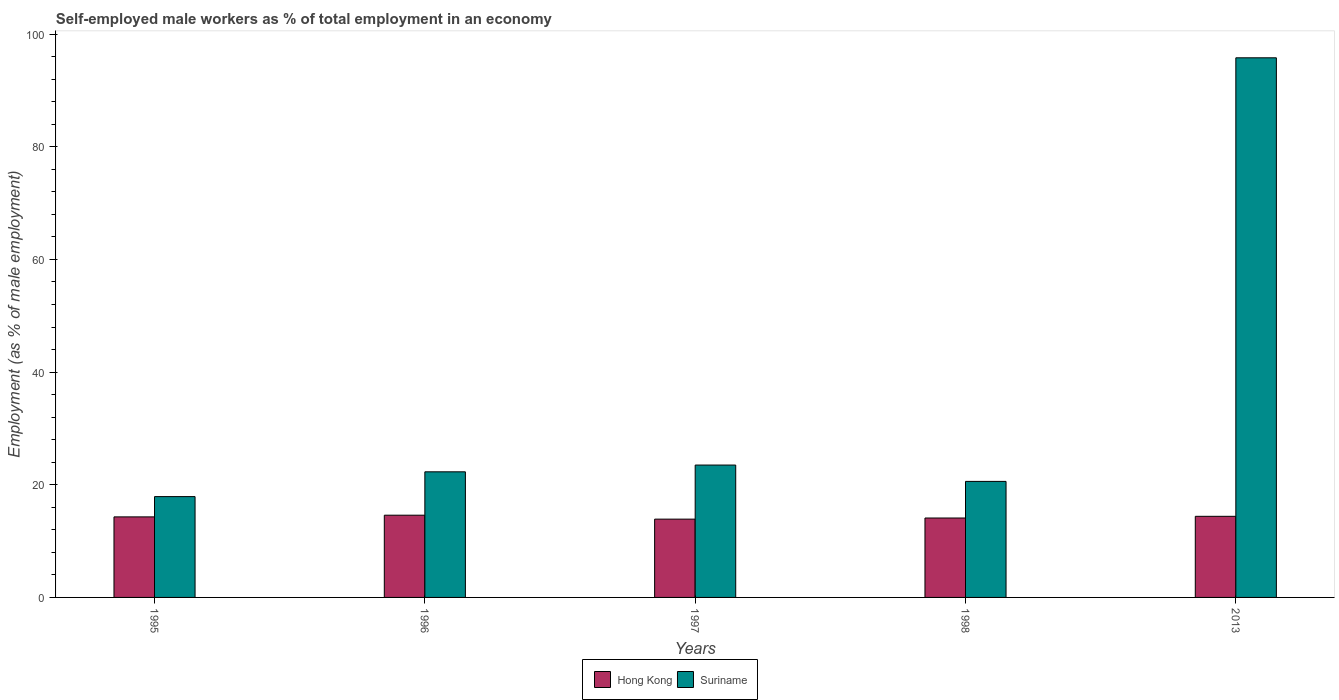Are the number of bars per tick equal to the number of legend labels?
Provide a short and direct response. Yes. How many bars are there on the 5th tick from the left?
Ensure brevity in your answer.  2. How many bars are there on the 1st tick from the right?
Offer a terse response. 2. Across all years, what is the maximum percentage of self-employed male workers in Hong Kong?
Your response must be concise. 14.6. Across all years, what is the minimum percentage of self-employed male workers in Suriname?
Provide a succinct answer. 17.9. In which year was the percentage of self-employed male workers in Suriname minimum?
Ensure brevity in your answer.  1995. What is the total percentage of self-employed male workers in Hong Kong in the graph?
Your response must be concise. 71.3. What is the difference between the percentage of self-employed male workers in Hong Kong in 2013 and the percentage of self-employed male workers in Suriname in 1995?
Provide a succinct answer. -3.5. What is the average percentage of self-employed male workers in Hong Kong per year?
Your answer should be very brief. 14.26. In the year 1998, what is the difference between the percentage of self-employed male workers in Hong Kong and percentage of self-employed male workers in Suriname?
Provide a short and direct response. -6.5. What is the ratio of the percentage of self-employed male workers in Hong Kong in 1997 to that in 1998?
Give a very brief answer. 0.99. Is the percentage of self-employed male workers in Suriname in 1997 less than that in 1998?
Make the answer very short. No. Is the difference between the percentage of self-employed male workers in Hong Kong in 1997 and 2013 greater than the difference between the percentage of self-employed male workers in Suriname in 1997 and 2013?
Offer a very short reply. Yes. What is the difference between the highest and the second highest percentage of self-employed male workers in Suriname?
Provide a short and direct response. 72.3. What is the difference between the highest and the lowest percentage of self-employed male workers in Suriname?
Your response must be concise. 77.9. In how many years, is the percentage of self-employed male workers in Hong Kong greater than the average percentage of self-employed male workers in Hong Kong taken over all years?
Your answer should be compact. 3. Is the sum of the percentage of self-employed male workers in Suriname in 1998 and 2013 greater than the maximum percentage of self-employed male workers in Hong Kong across all years?
Provide a short and direct response. Yes. What does the 1st bar from the left in 2013 represents?
Ensure brevity in your answer.  Hong Kong. What does the 2nd bar from the right in 1995 represents?
Give a very brief answer. Hong Kong. Are all the bars in the graph horizontal?
Your answer should be very brief. No. How many years are there in the graph?
Provide a succinct answer. 5. What is the difference between two consecutive major ticks on the Y-axis?
Offer a terse response. 20. Does the graph contain any zero values?
Keep it short and to the point. No. What is the title of the graph?
Your response must be concise. Self-employed male workers as % of total employment in an economy. What is the label or title of the Y-axis?
Give a very brief answer. Employment (as % of male employment). What is the Employment (as % of male employment) of Hong Kong in 1995?
Your answer should be compact. 14.3. What is the Employment (as % of male employment) in Suriname in 1995?
Your answer should be compact. 17.9. What is the Employment (as % of male employment) in Hong Kong in 1996?
Make the answer very short. 14.6. What is the Employment (as % of male employment) in Suriname in 1996?
Your answer should be compact. 22.3. What is the Employment (as % of male employment) in Hong Kong in 1997?
Provide a short and direct response. 13.9. What is the Employment (as % of male employment) of Suriname in 1997?
Provide a succinct answer. 23.5. What is the Employment (as % of male employment) in Hong Kong in 1998?
Provide a succinct answer. 14.1. What is the Employment (as % of male employment) in Suriname in 1998?
Offer a terse response. 20.6. What is the Employment (as % of male employment) of Hong Kong in 2013?
Ensure brevity in your answer.  14.4. What is the Employment (as % of male employment) in Suriname in 2013?
Give a very brief answer. 95.8. Across all years, what is the maximum Employment (as % of male employment) of Hong Kong?
Provide a short and direct response. 14.6. Across all years, what is the maximum Employment (as % of male employment) in Suriname?
Make the answer very short. 95.8. Across all years, what is the minimum Employment (as % of male employment) of Hong Kong?
Keep it short and to the point. 13.9. Across all years, what is the minimum Employment (as % of male employment) of Suriname?
Your answer should be very brief. 17.9. What is the total Employment (as % of male employment) of Hong Kong in the graph?
Your response must be concise. 71.3. What is the total Employment (as % of male employment) in Suriname in the graph?
Your answer should be compact. 180.1. What is the difference between the Employment (as % of male employment) in Suriname in 1995 and that in 1996?
Offer a very short reply. -4.4. What is the difference between the Employment (as % of male employment) of Hong Kong in 1995 and that in 1998?
Your response must be concise. 0.2. What is the difference between the Employment (as % of male employment) of Suriname in 1995 and that in 1998?
Ensure brevity in your answer.  -2.7. What is the difference between the Employment (as % of male employment) of Suriname in 1995 and that in 2013?
Give a very brief answer. -77.9. What is the difference between the Employment (as % of male employment) in Hong Kong in 1996 and that in 1997?
Give a very brief answer. 0.7. What is the difference between the Employment (as % of male employment) of Suriname in 1996 and that in 1997?
Give a very brief answer. -1.2. What is the difference between the Employment (as % of male employment) in Hong Kong in 1996 and that in 2013?
Make the answer very short. 0.2. What is the difference between the Employment (as % of male employment) in Suriname in 1996 and that in 2013?
Keep it short and to the point. -73.5. What is the difference between the Employment (as % of male employment) in Hong Kong in 1997 and that in 1998?
Provide a succinct answer. -0.2. What is the difference between the Employment (as % of male employment) in Hong Kong in 1997 and that in 2013?
Keep it short and to the point. -0.5. What is the difference between the Employment (as % of male employment) of Suriname in 1997 and that in 2013?
Keep it short and to the point. -72.3. What is the difference between the Employment (as % of male employment) of Hong Kong in 1998 and that in 2013?
Make the answer very short. -0.3. What is the difference between the Employment (as % of male employment) in Suriname in 1998 and that in 2013?
Offer a terse response. -75.2. What is the difference between the Employment (as % of male employment) in Hong Kong in 1995 and the Employment (as % of male employment) in Suriname in 1996?
Your answer should be very brief. -8. What is the difference between the Employment (as % of male employment) of Hong Kong in 1995 and the Employment (as % of male employment) of Suriname in 1997?
Offer a terse response. -9.2. What is the difference between the Employment (as % of male employment) of Hong Kong in 1995 and the Employment (as % of male employment) of Suriname in 1998?
Keep it short and to the point. -6.3. What is the difference between the Employment (as % of male employment) in Hong Kong in 1995 and the Employment (as % of male employment) in Suriname in 2013?
Keep it short and to the point. -81.5. What is the difference between the Employment (as % of male employment) of Hong Kong in 1996 and the Employment (as % of male employment) of Suriname in 1997?
Ensure brevity in your answer.  -8.9. What is the difference between the Employment (as % of male employment) in Hong Kong in 1996 and the Employment (as % of male employment) in Suriname in 1998?
Offer a terse response. -6. What is the difference between the Employment (as % of male employment) of Hong Kong in 1996 and the Employment (as % of male employment) of Suriname in 2013?
Give a very brief answer. -81.2. What is the difference between the Employment (as % of male employment) in Hong Kong in 1997 and the Employment (as % of male employment) in Suriname in 2013?
Give a very brief answer. -81.9. What is the difference between the Employment (as % of male employment) of Hong Kong in 1998 and the Employment (as % of male employment) of Suriname in 2013?
Provide a succinct answer. -81.7. What is the average Employment (as % of male employment) of Hong Kong per year?
Your answer should be very brief. 14.26. What is the average Employment (as % of male employment) of Suriname per year?
Give a very brief answer. 36.02. In the year 1996, what is the difference between the Employment (as % of male employment) in Hong Kong and Employment (as % of male employment) in Suriname?
Offer a terse response. -7.7. In the year 1998, what is the difference between the Employment (as % of male employment) of Hong Kong and Employment (as % of male employment) of Suriname?
Provide a short and direct response. -6.5. In the year 2013, what is the difference between the Employment (as % of male employment) in Hong Kong and Employment (as % of male employment) in Suriname?
Your answer should be compact. -81.4. What is the ratio of the Employment (as % of male employment) in Hong Kong in 1995 to that in 1996?
Offer a terse response. 0.98. What is the ratio of the Employment (as % of male employment) in Suriname in 1995 to that in 1996?
Your response must be concise. 0.8. What is the ratio of the Employment (as % of male employment) of Hong Kong in 1995 to that in 1997?
Your answer should be compact. 1.03. What is the ratio of the Employment (as % of male employment) of Suriname in 1995 to that in 1997?
Give a very brief answer. 0.76. What is the ratio of the Employment (as % of male employment) in Hong Kong in 1995 to that in 1998?
Offer a very short reply. 1.01. What is the ratio of the Employment (as % of male employment) of Suriname in 1995 to that in 1998?
Your answer should be very brief. 0.87. What is the ratio of the Employment (as % of male employment) of Suriname in 1995 to that in 2013?
Ensure brevity in your answer.  0.19. What is the ratio of the Employment (as % of male employment) in Hong Kong in 1996 to that in 1997?
Give a very brief answer. 1.05. What is the ratio of the Employment (as % of male employment) of Suriname in 1996 to that in 1997?
Your answer should be compact. 0.95. What is the ratio of the Employment (as % of male employment) in Hong Kong in 1996 to that in 1998?
Your response must be concise. 1.04. What is the ratio of the Employment (as % of male employment) of Suriname in 1996 to that in 1998?
Your response must be concise. 1.08. What is the ratio of the Employment (as % of male employment) of Hong Kong in 1996 to that in 2013?
Make the answer very short. 1.01. What is the ratio of the Employment (as % of male employment) of Suriname in 1996 to that in 2013?
Give a very brief answer. 0.23. What is the ratio of the Employment (as % of male employment) of Hong Kong in 1997 to that in 1998?
Provide a short and direct response. 0.99. What is the ratio of the Employment (as % of male employment) of Suriname in 1997 to that in 1998?
Make the answer very short. 1.14. What is the ratio of the Employment (as % of male employment) in Hong Kong in 1997 to that in 2013?
Give a very brief answer. 0.97. What is the ratio of the Employment (as % of male employment) in Suriname in 1997 to that in 2013?
Keep it short and to the point. 0.25. What is the ratio of the Employment (as % of male employment) in Hong Kong in 1998 to that in 2013?
Make the answer very short. 0.98. What is the ratio of the Employment (as % of male employment) of Suriname in 1998 to that in 2013?
Give a very brief answer. 0.21. What is the difference between the highest and the second highest Employment (as % of male employment) of Suriname?
Your answer should be very brief. 72.3. What is the difference between the highest and the lowest Employment (as % of male employment) in Suriname?
Provide a succinct answer. 77.9. 